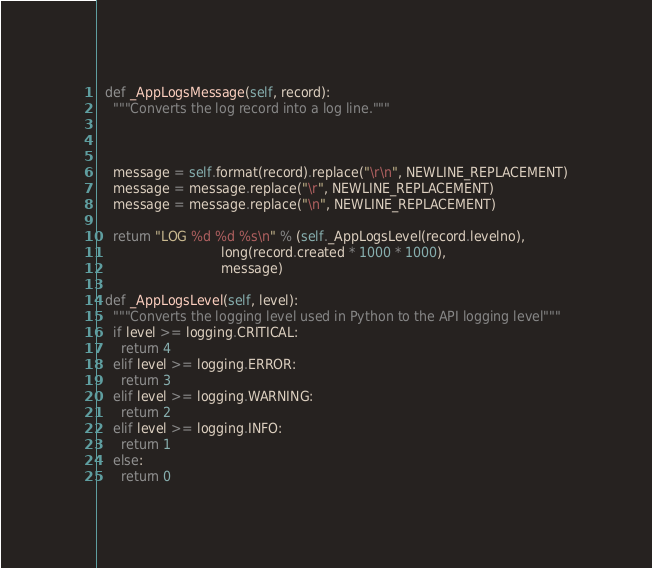Convert code to text. <code><loc_0><loc_0><loc_500><loc_500><_Python_>
  def _AppLogsMessage(self, record):
    """Converts the log record into a log line."""



    message = self.format(record).replace("\r\n", NEWLINE_REPLACEMENT)
    message = message.replace("\r", NEWLINE_REPLACEMENT)
    message = message.replace("\n", NEWLINE_REPLACEMENT)

    return "LOG %d %d %s\n" % (self._AppLogsLevel(record.levelno),
                               long(record.created * 1000 * 1000),
                               message)

  def _AppLogsLevel(self, level):
    """Converts the logging level used in Python to the API logging level"""
    if level >= logging.CRITICAL:
      return 4
    elif level >= logging.ERROR:
      return 3
    elif level >= logging.WARNING:
      return 2
    elif level >= logging.INFO:
      return 1
    else:
      return 0
</code> 